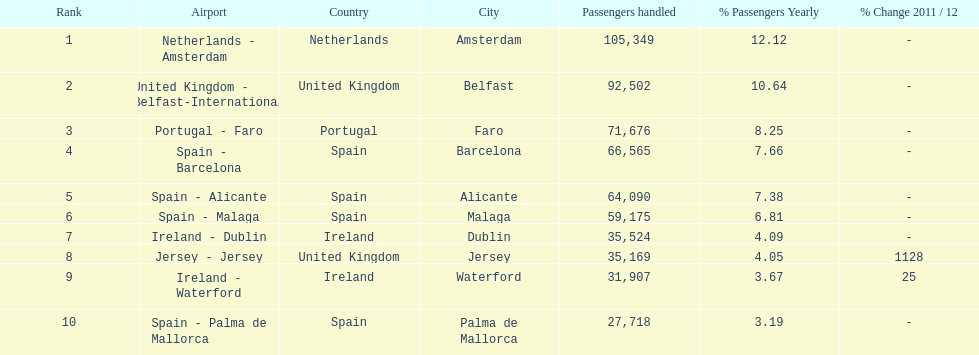Between the topped ranked airport, netherlands - amsterdam, & spain - palma de mallorca, what is the difference in the amount of passengers handled? 77,631. 